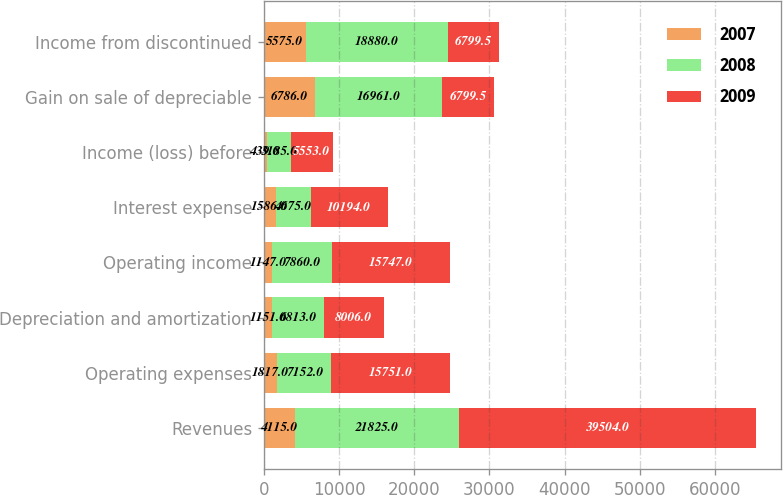Convert chart. <chart><loc_0><loc_0><loc_500><loc_500><stacked_bar_chart><ecel><fcel>Revenues<fcel>Operating expenses<fcel>Depreciation and amortization<fcel>Operating income<fcel>Interest expense<fcel>Income (loss) before<fcel>Gain on sale of depreciable<fcel>Income from discontinued<nl><fcel>2007<fcel>4115<fcel>1817<fcel>1151<fcel>1147<fcel>1586<fcel>439<fcel>6786<fcel>5575<nl><fcel>2008<fcel>21825<fcel>7152<fcel>6813<fcel>7860<fcel>4675<fcel>3185<fcel>16961<fcel>18880<nl><fcel>2009<fcel>39504<fcel>15751<fcel>8006<fcel>15747<fcel>10194<fcel>5553<fcel>6799.5<fcel>6799.5<nl></chart> 